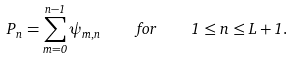Convert formula to latex. <formula><loc_0><loc_0><loc_500><loc_500>P _ { n } = \sum _ { m = 0 } ^ { n - 1 } \psi _ { m , n } \quad f o r \quad 1 \leq n \leq L + 1 .</formula> 